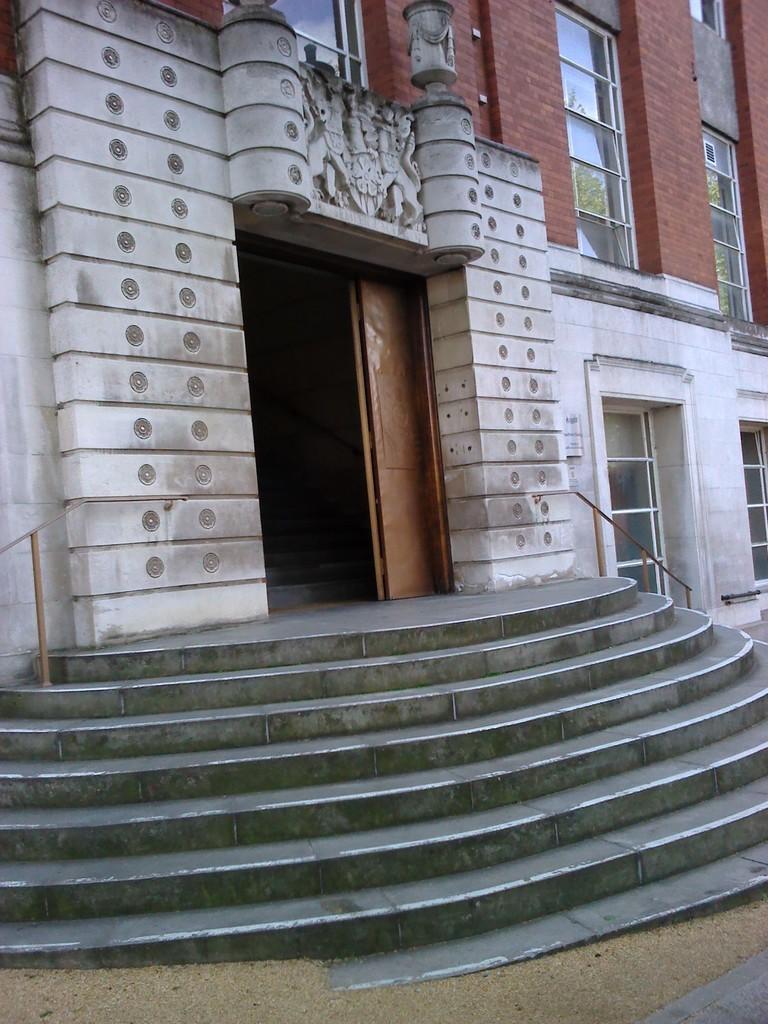Please provide a concise description of this image. In this picture we can see a building, windows, door and stairs. We can see carvings on the wall. At the bottom portion of the picture we can see the sand. 